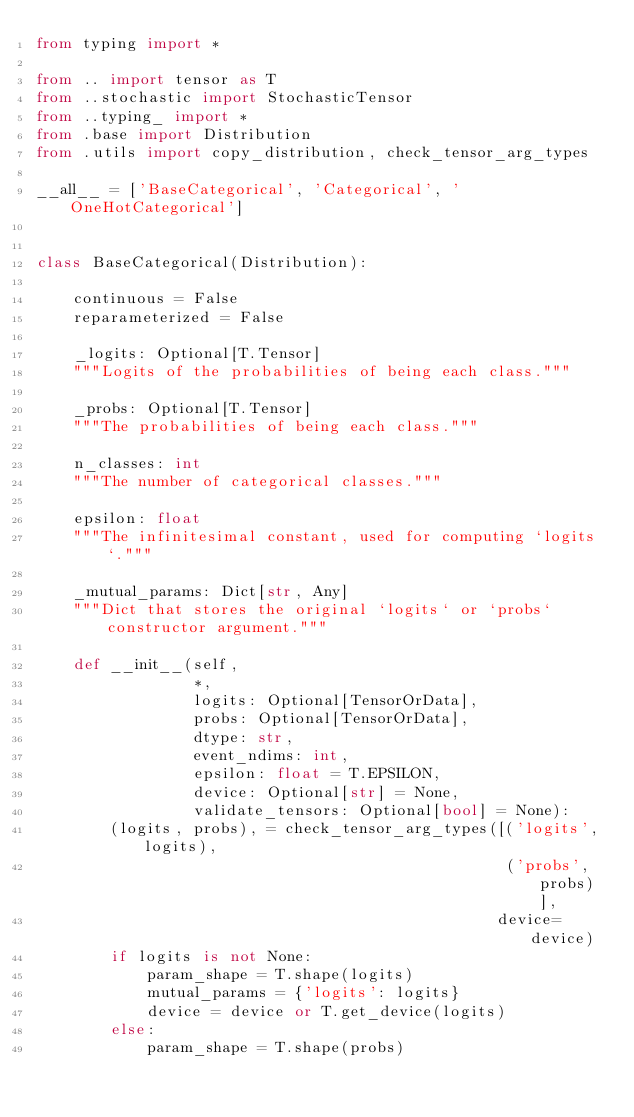Convert code to text. <code><loc_0><loc_0><loc_500><loc_500><_Python_>from typing import *

from .. import tensor as T
from ..stochastic import StochasticTensor
from ..typing_ import *
from .base import Distribution
from .utils import copy_distribution, check_tensor_arg_types

__all__ = ['BaseCategorical', 'Categorical', 'OneHotCategorical']


class BaseCategorical(Distribution):

    continuous = False
    reparameterized = False

    _logits: Optional[T.Tensor]
    """Logits of the probabilities of being each class."""

    _probs: Optional[T.Tensor]
    """The probabilities of being each class."""

    n_classes: int
    """The number of categorical classes."""

    epsilon: float
    """The infinitesimal constant, used for computing `logits`."""

    _mutual_params: Dict[str, Any]
    """Dict that stores the original `logits` or `probs` constructor argument."""

    def __init__(self,
                 *,
                 logits: Optional[TensorOrData],
                 probs: Optional[TensorOrData],
                 dtype: str,
                 event_ndims: int,
                 epsilon: float = T.EPSILON,
                 device: Optional[str] = None,
                 validate_tensors: Optional[bool] = None):
        (logits, probs), = check_tensor_arg_types([('logits', logits),
                                                   ('probs', probs)],
                                                  device=device)
        if logits is not None:
            param_shape = T.shape(logits)
            mutual_params = {'logits': logits}
            device = device or T.get_device(logits)
        else:
            param_shape = T.shape(probs)</code> 